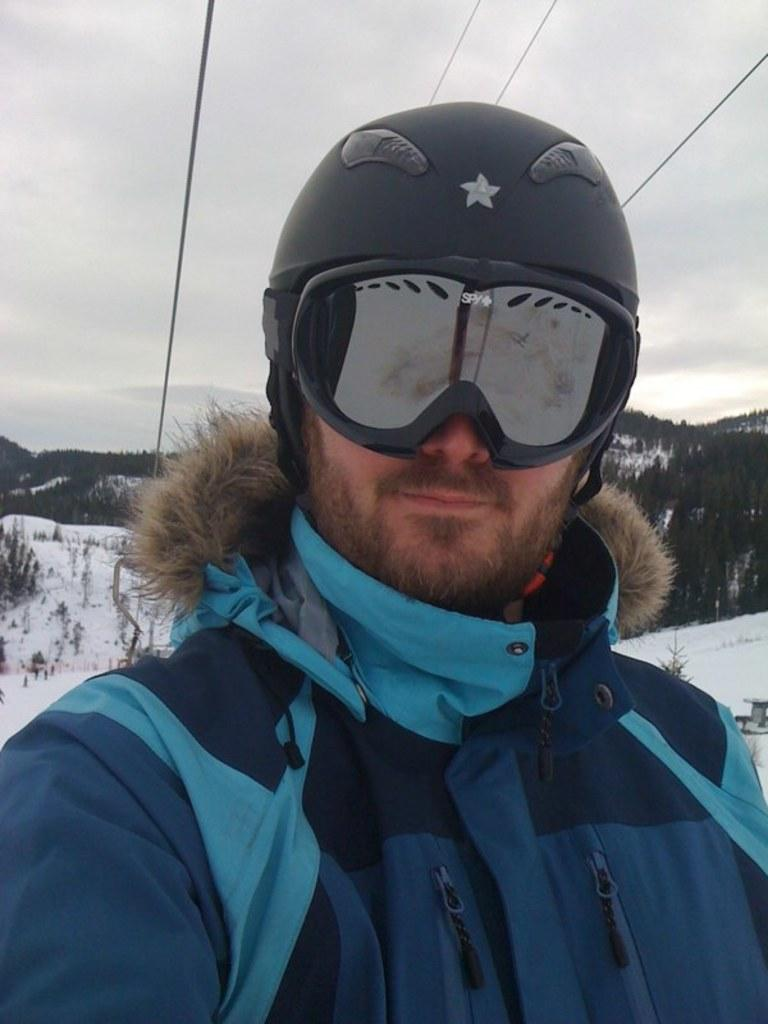Who is the main subject in the image? There is a person in the center of the image. What protective gear is the person wearing? The person is wearing a helmet and glasses. What type of environment is depicted in the background? There are many trees in the background of the image. What is the weather like in the image? Snow is visible in the image, and the sky is cloudy. What type of furniture can be seen in the image? There is no furniture present in the image. Is the person's brother also wearing a helmet and glasses in the image? The provided facts do not mention the presence of a brother or any other person in the image, so we cannot determine if they are wearing a helmet and glasses. 